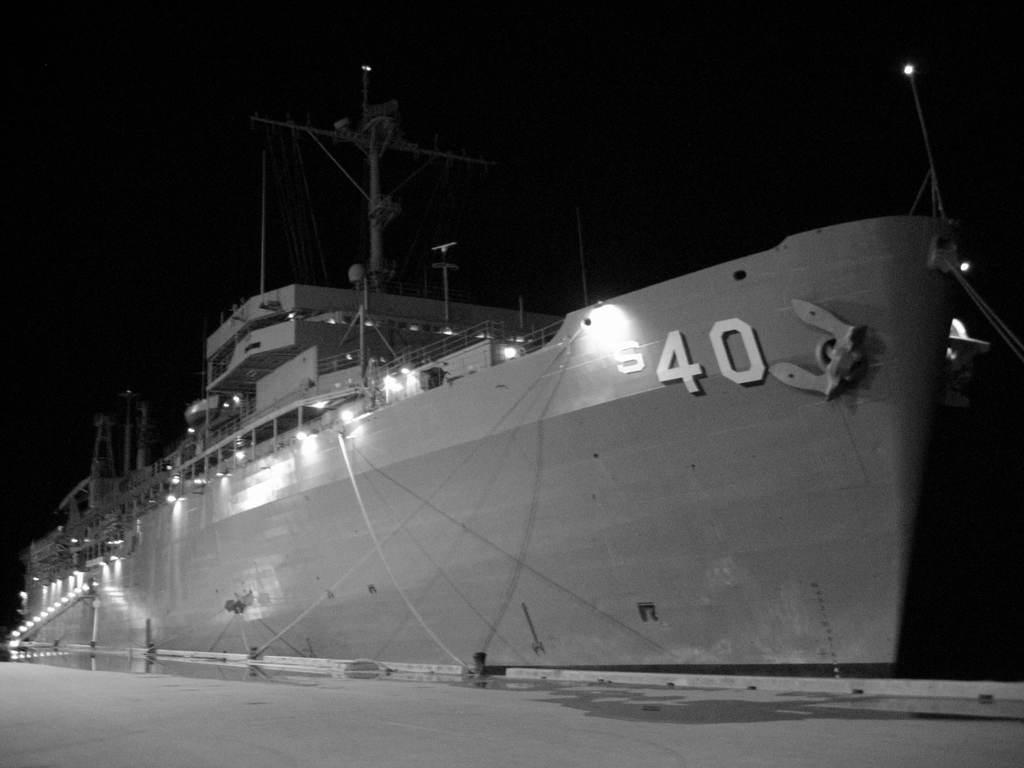Could you give a brief overview of what you see in this image? It is the black and white image in which we can see that there is a ship in the middle. At the bottom there is road. In the ship there is a building with lights. There is a number on the ship. 